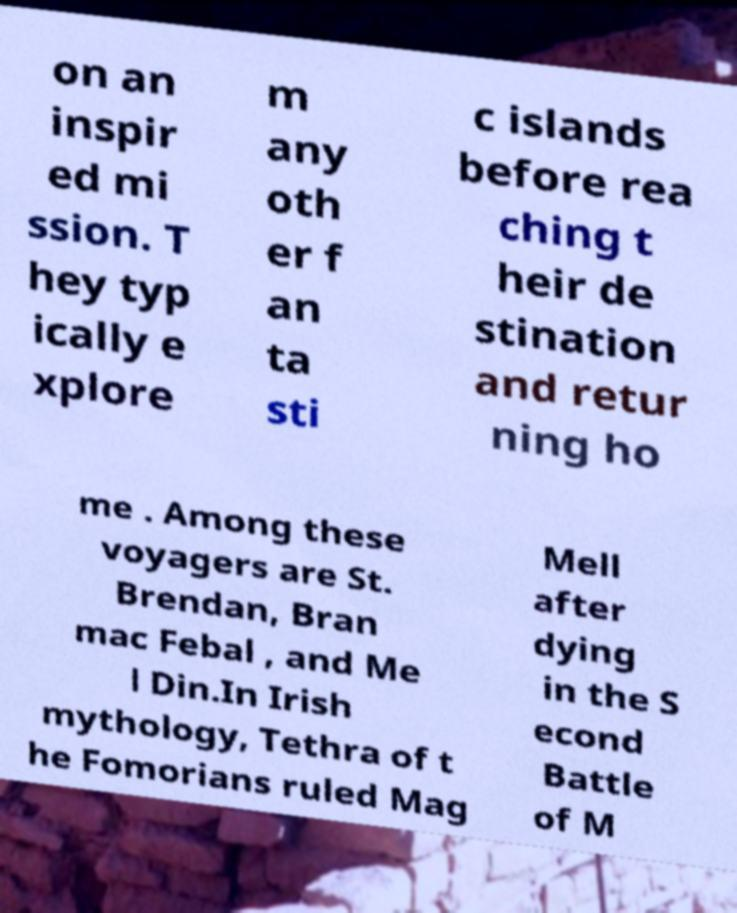There's text embedded in this image that I need extracted. Can you transcribe it verbatim? on an inspir ed mi ssion. T hey typ ically e xplore m any oth er f an ta sti c islands before rea ching t heir de stination and retur ning ho me . Among these voyagers are St. Brendan, Bran mac Febal , and Me l Din.In Irish mythology, Tethra of t he Fomorians ruled Mag Mell after dying in the S econd Battle of M 